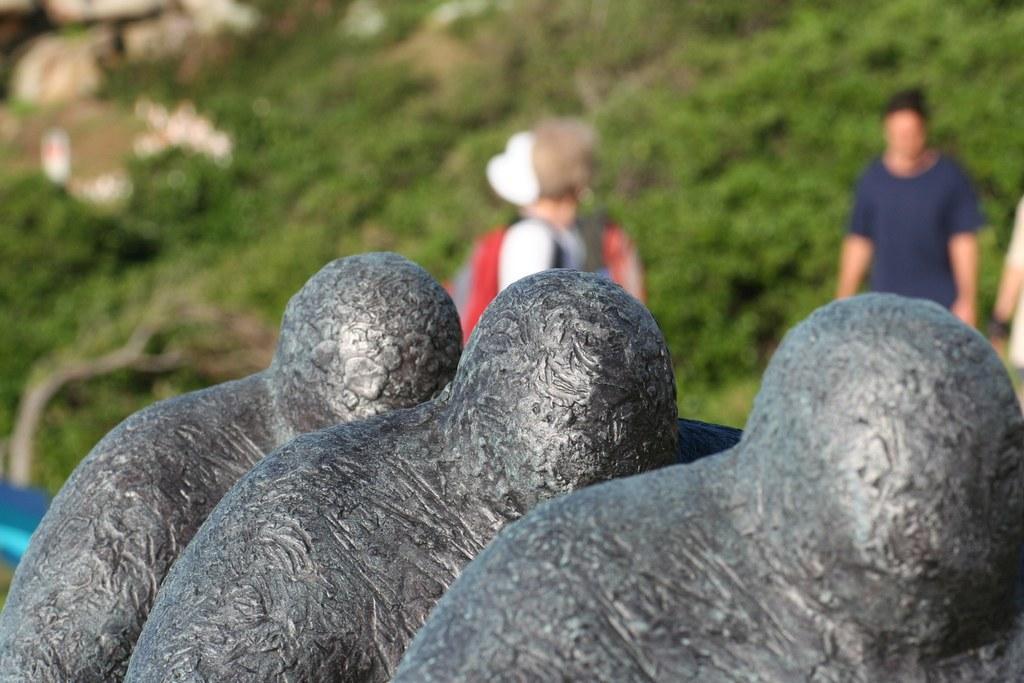Can you describe this image briefly? In this picture we can see sculptures. In the background of the image it is blurry and we can see people. 